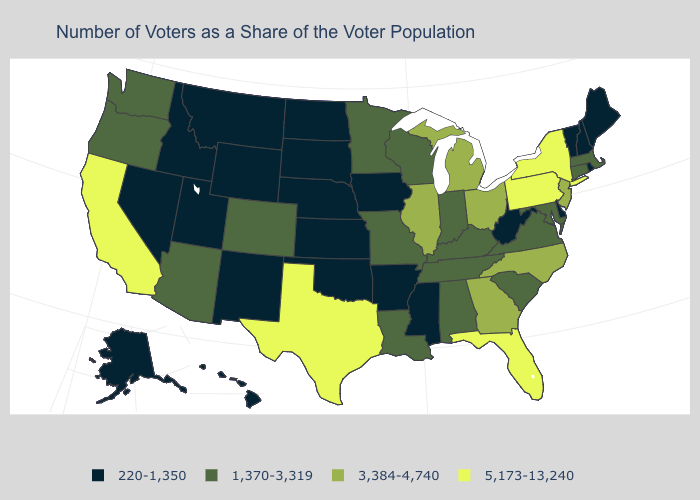What is the value of Wyoming?
Concise answer only. 220-1,350. Which states hav the highest value in the South?
Be succinct. Florida, Texas. Is the legend a continuous bar?
Keep it brief. No. Which states have the lowest value in the USA?
Short answer required. Alaska, Arkansas, Delaware, Hawaii, Idaho, Iowa, Kansas, Maine, Mississippi, Montana, Nebraska, Nevada, New Hampshire, New Mexico, North Dakota, Oklahoma, Rhode Island, South Dakota, Utah, Vermont, West Virginia, Wyoming. Does Connecticut have a lower value than Ohio?
Answer briefly. Yes. What is the value of South Dakota?
Give a very brief answer. 220-1,350. Does Massachusetts have a lower value than Connecticut?
Give a very brief answer. No. Is the legend a continuous bar?
Keep it brief. No. What is the lowest value in the USA?
Concise answer only. 220-1,350. Does Alaska have the highest value in the West?
Short answer required. No. Which states have the lowest value in the MidWest?
Be succinct. Iowa, Kansas, Nebraska, North Dakota, South Dakota. Name the states that have a value in the range 5,173-13,240?
Quick response, please. California, Florida, New York, Pennsylvania, Texas. What is the value of Hawaii?
Be succinct. 220-1,350. Name the states that have a value in the range 220-1,350?
Be succinct. Alaska, Arkansas, Delaware, Hawaii, Idaho, Iowa, Kansas, Maine, Mississippi, Montana, Nebraska, Nevada, New Hampshire, New Mexico, North Dakota, Oklahoma, Rhode Island, South Dakota, Utah, Vermont, West Virginia, Wyoming. Does Ohio have a lower value than Wisconsin?
Give a very brief answer. No. 